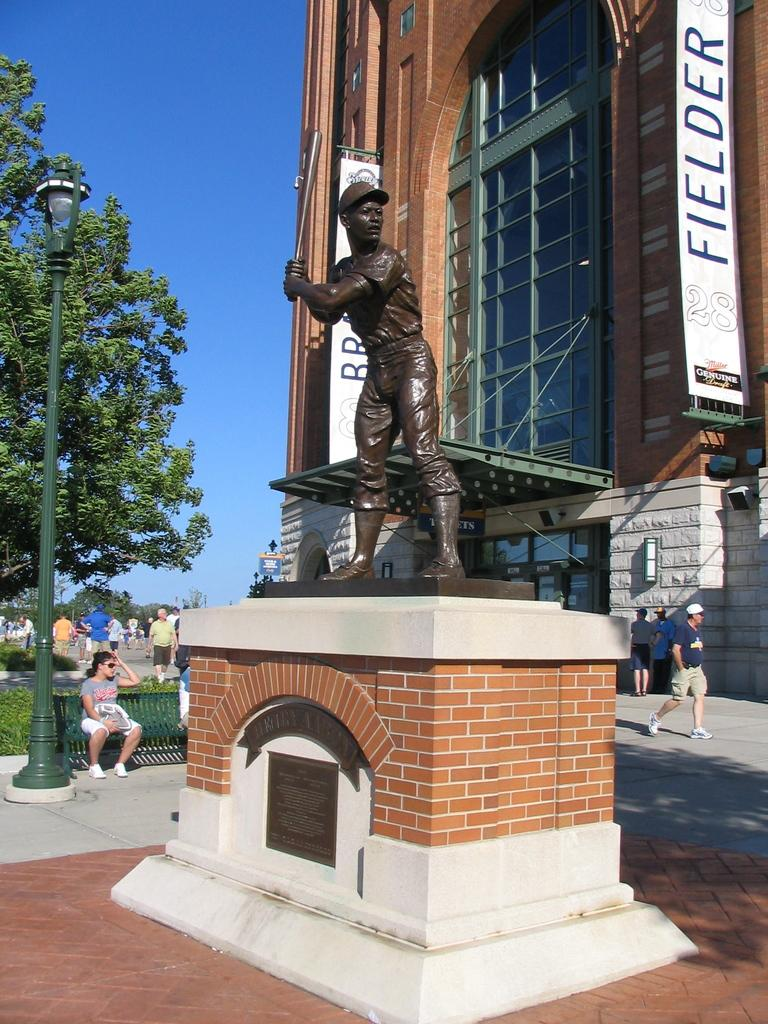<image>
Share a concise interpretation of the image provided. A statue outside of a building called "Fielder" 